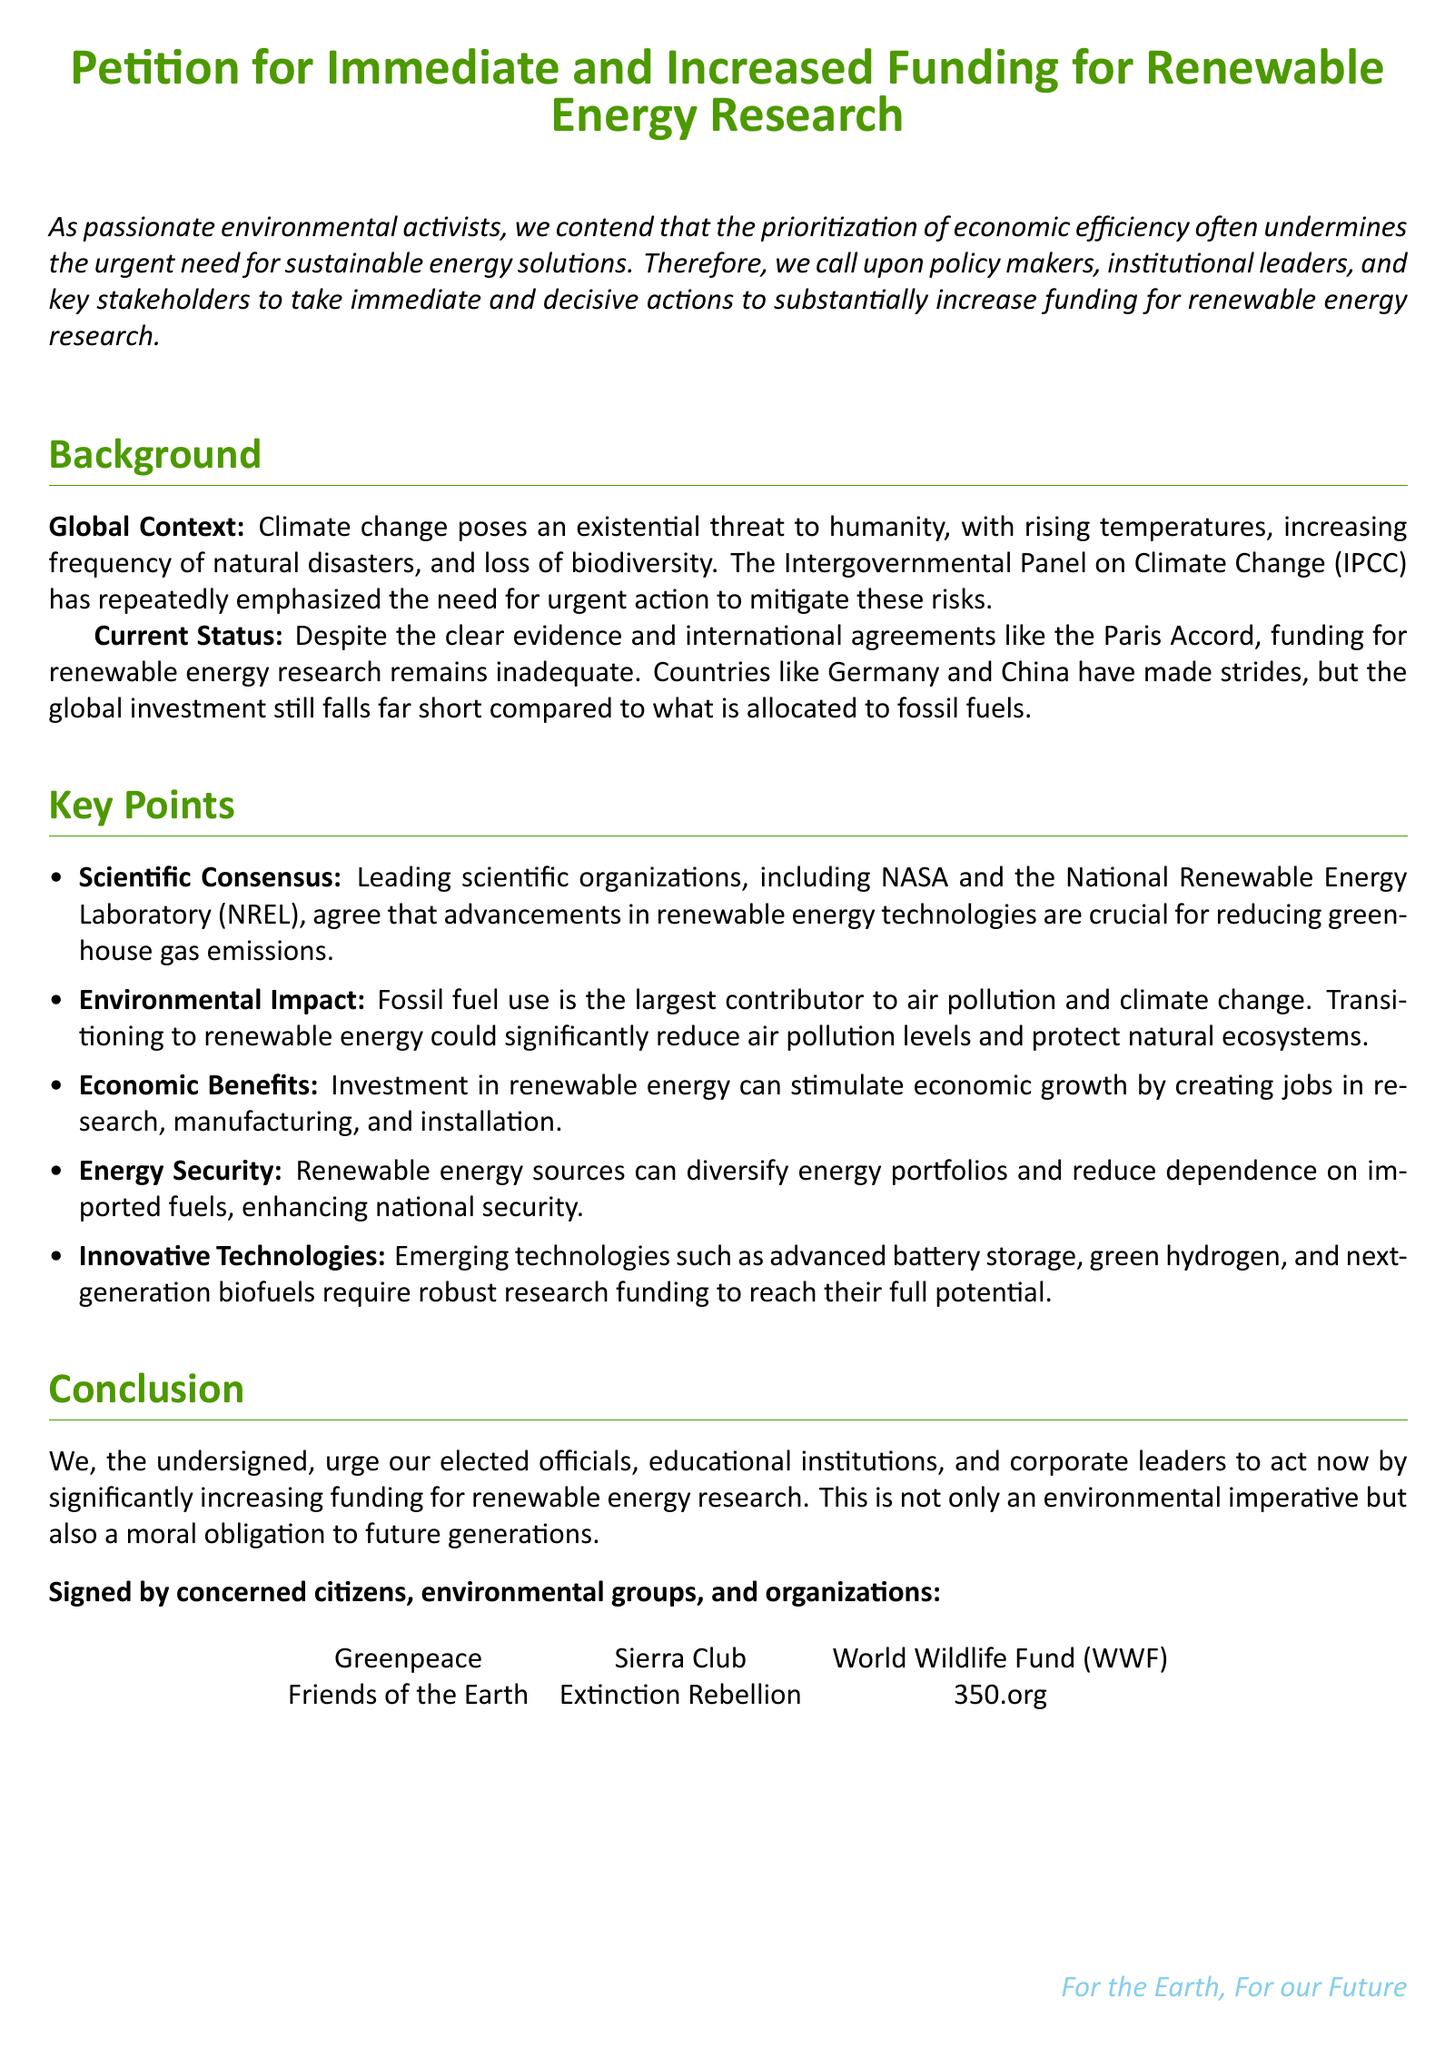What is the title of the petition? The title is prominently displayed at the beginning of the document.
Answer: Petition for Immediate and Increased Funding for Renewable Energy Research Who are the organizations that signed the petition? The document lists several environmental organizations at the end.
Answer: Greenpeace, Sierra Club, World Wildlife Fund (WWF), Friends of the Earth, Extinction Rebellion, 350.org Which major international agreement is mentioned? The background section refers to this agreement in the context of renewable energy funding.
Answer: Paris Accord What is the primary environmental issue highlighted? The background section addresses the most pressing global challenge.
Answer: Climate change Which organization is specifically mentioned as supporting the need for renewable energy advancements? The key points section cites organizations that agree on this matter.
Answer: NASA What is one potential economic benefit of investing in renewable energy? The document states economic benefits in the key points section.
Answer: Creating jobs What is one of the innovative technologies mentioned that requires research funding? The document lists technologies in the key points section that need robust funding.
Answer: Advanced battery storage What is the main conclusion of the petition? The conclusion summarizes the urgent call for actions addressed in the document.
Answer: Increase funding for renewable energy research What is the color used for the titles in the document? The document specifies a color for formatting in the title section.
Answer: Earthgreen 